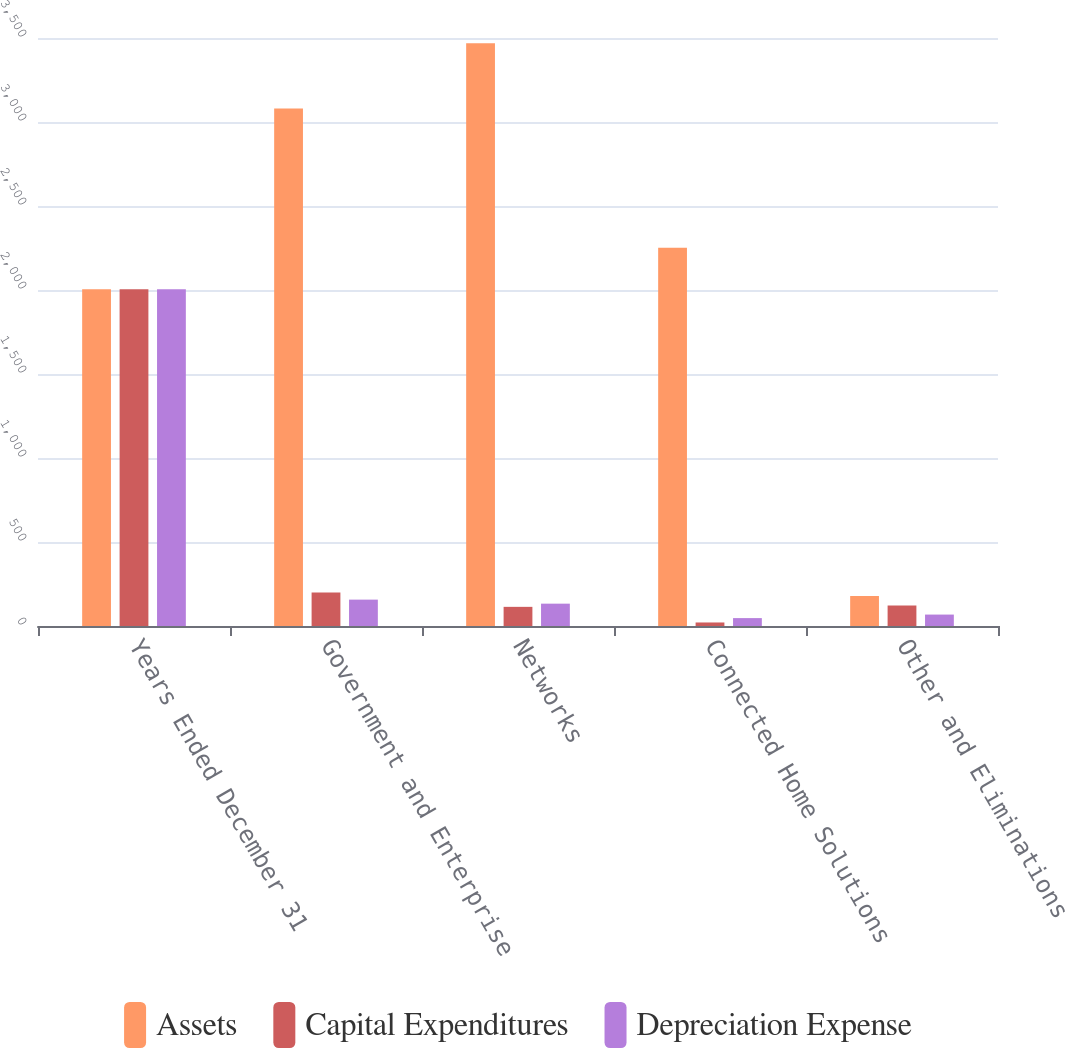Convert chart to OTSL. <chart><loc_0><loc_0><loc_500><loc_500><stacked_bar_chart><ecel><fcel>Years Ended December 31<fcel>Government and Enterprise<fcel>Networks<fcel>Connected Home Solutions<fcel>Other and Eliminations<nl><fcel>Assets<fcel>2005<fcel>3080<fcel>3469<fcel>2252<fcel>178.5<nl><fcel>Capital Expenditures<fcel>2005<fcel>200<fcel>114<fcel>21<fcel>122<nl><fcel>Depreciation Expense<fcel>2005<fcel>157<fcel>133<fcel>47<fcel>68<nl></chart> 